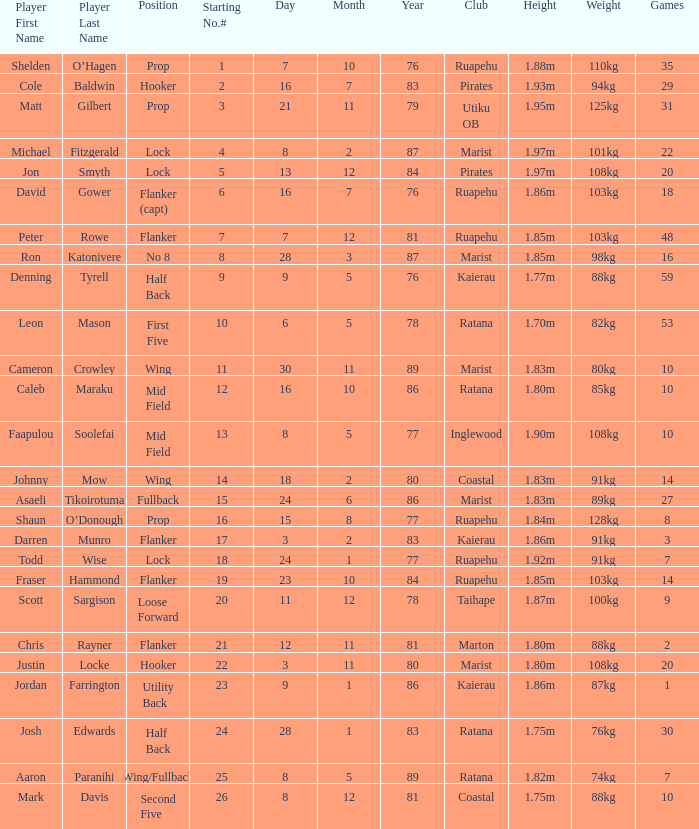Could you parse the entire table as a dict? {'header': ['Player First Name', 'Player Last Name', 'Position', 'Starting No.#', 'Day', 'Month', 'Year', 'Club', 'Height', 'Weight', 'Games'], 'rows': [['Shelden', 'O’Hagen', 'Prop', '1', '7', '10', '76', 'Ruapehu', '1.88m', '110kg', '35'], ['Cole', 'Baldwin', 'Hooker', '2', '16', '7', '83', 'Pirates', '1.93m', '94kg', '29'], ['Matt', 'Gilbert', 'Prop', '3', '21', '11', '79', 'Utiku OB', '1.95m', '125kg', '31'], ['Michael', 'Fitzgerald', 'Lock', '4', '8', '2', '87', 'Marist', '1.97m', '101kg', '22'], ['Jon', 'Smyth', 'Lock', '5', '13', '12', '84', 'Pirates', '1.97m', '108kg', '20'], ['David', 'Gower', 'Flanker (capt)', '6', '16', '7', '76', 'Ruapehu', '1.86m', '103kg', '18'], ['Peter', 'Rowe', 'Flanker', '7', '7', '12', '81', 'Ruapehu', '1.85m', '103kg', '48'], ['Ron', 'Katonivere', 'No 8', '8', '28', '3', '87', 'Marist', '1.85m', '98kg', '16'], ['Denning', 'Tyrell', 'Half Back', '9', '9', '5', '76', 'Kaierau', '1.77m', '88kg', '59'], ['Leon', 'Mason', 'First Five', '10', '6', '5', '78', 'Ratana', '1.70m', '82kg', '53'], ['Cameron', 'Crowley', 'Wing', '11', '30', '11', '89', 'Marist', '1.83m', '80kg', '10'], ['Caleb', 'Maraku', 'Mid Field', '12', '16', '10', '86', 'Ratana', '1.80m', '85kg', '10'], ['Faapulou', 'Soolefai', 'Mid Field', '13', '8', '5', '77', 'Inglewood', '1.90m', '108kg', '10'], ['Johnny', 'Mow', 'Wing', '14', '18', '2', '80', 'Coastal', '1.83m', '91kg', '14'], ['Asaeli', 'Tikoirotuma', 'Fullback', '15', '24', '6', '86', 'Marist', '1.83m', '89kg', '27'], ['Shaun', 'O’Donough', 'Prop', '16', '15', '8', '77', 'Ruapehu', '1.84m', '128kg', '8'], ['Darren', 'Munro', 'Flanker', '17', '3', '2', '83', 'Kaierau', '1.86m', '91kg', '3'], ['Todd', 'Wise', 'Lock', '18', '24', '1', '77', 'Ruapehu', '1.92m', '91kg', '7'], ['Fraser', 'Hammond', 'Flanker', '19', '23', '10', '84', 'Ruapehu', '1.85m', '103kg', '14'], ['Scott', 'Sargison', 'Loose Forward', '20', '11', '12', '78', 'Taihape', '1.87m', '100kg', '9'], ['Chris', 'Rayner', 'Flanker', '21', '12', '11', '81', 'Marton', '1.80m', '88kg', '2'], ['Justin', 'Locke', 'Hooker', '22', '3', '11', '80', 'Marist', '1.80m', '108kg', '20'], ['Jordan', 'Farrington', 'Utility Back', '23', '9', '1', '86', 'Kaierau', '1.86m', '87kg', '1'], ['Josh', 'Edwards', 'Half Back', '24', '28', '1', '83', 'Ratana', '1.75m', '76kg', '30'], ['Aaron', 'Paranihi', 'Wing/Fullback', '25', '8', '5', '89', 'Ratana', '1.82m', '74kg', '7'], ['Mark', 'Davis', 'Second Five', '26', '8', '12', '81', 'Coastal', '1.75m', '88kg', '10']]} Can you tell me the player's date of birth in the inglewood club? 80577.0. 